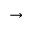Convert formula to latex. <formula><loc_0><loc_0><loc_500><loc_500>\rightarrow</formula> 